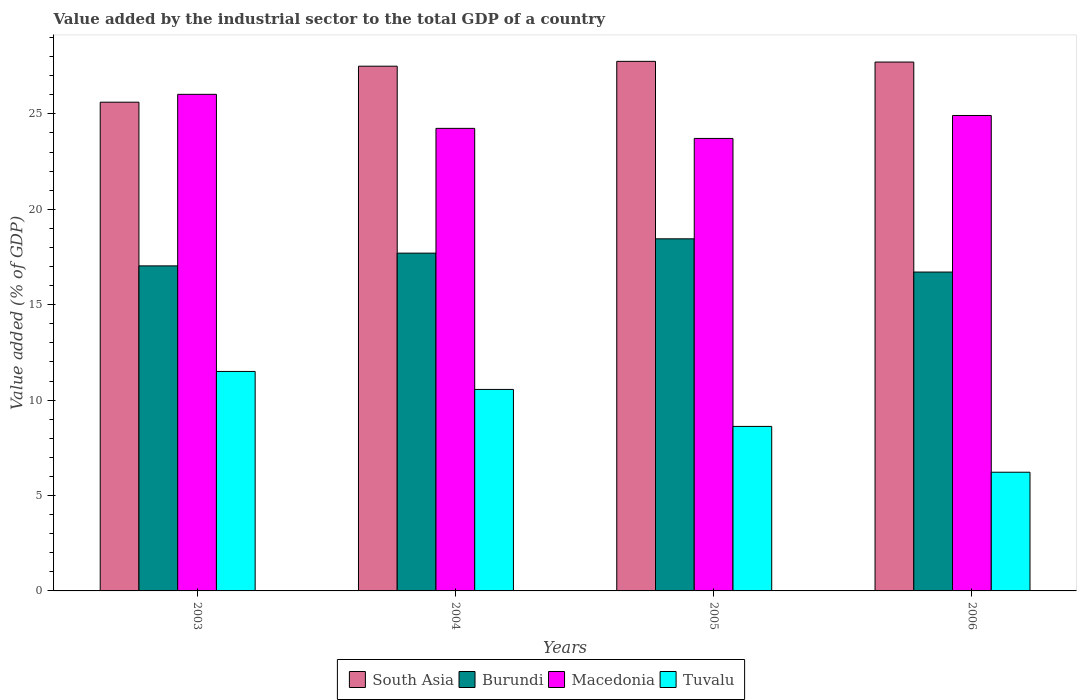How many bars are there on the 3rd tick from the left?
Make the answer very short. 4. What is the label of the 2nd group of bars from the left?
Provide a succinct answer. 2004. What is the value added by the industrial sector to the total GDP in Burundi in 2003?
Provide a short and direct response. 17.03. Across all years, what is the maximum value added by the industrial sector to the total GDP in Macedonia?
Your answer should be compact. 26.03. Across all years, what is the minimum value added by the industrial sector to the total GDP in Burundi?
Offer a very short reply. 16.71. What is the total value added by the industrial sector to the total GDP in Tuvalu in the graph?
Offer a very short reply. 36.9. What is the difference between the value added by the industrial sector to the total GDP in South Asia in 2004 and that in 2006?
Make the answer very short. -0.22. What is the difference between the value added by the industrial sector to the total GDP in Tuvalu in 2006 and the value added by the industrial sector to the total GDP in Burundi in 2004?
Make the answer very short. -11.48. What is the average value added by the industrial sector to the total GDP in Macedonia per year?
Your answer should be compact. 24.72. In the year 2006, what is the difference between the value added by the industrial sector to the total GDP in Macedonia and value added by the industrial sector to the total GDP in South Asia?
Offer a terse response. -2.8. In how many years, is the value added by the industrial sector to the total GDP in Burundi greater than 18 %?
Provide a short and direct response. 1. What is the ratio of the value added by the industrial sector to the total GDP in Macedonia in 2005 to that in 2006?
Your answer should be compact. 0.95. Is the value added by the industrial sector to the total GDP in Tuvalu in 2005 less than that in 2006?
Give a very brief answer. No. What is the difference between the highest and the second highest value added by the industrial sector to the total GDP in Macedonia?
Your answer should be compact. 1.11. What is the difference between the highest and the lowest value added by the industrial sector to the total GDP in South Asia?
Make the answer very short. 2.14. In how many years, is the value added by the industrial sector to the total GDP in Macedonia greater than the average value added by the industrial sector to the total GDP in Macedonia taken over all years?
Provide a short and direct response. 2. What does the 3rd bar from the right in 2003 represents?
Offer a terse response. Burundi. Is it the case that in every year, the sum of the value added by the industrial sector to the total GDP in South Asia and value added by the industrial sector to the total GDP in Macedonia is greater than the value added by the industrial sector to the total GDP in Burundi?
Make the answer very short. Yes. Are all the bars in the graph horizontal?
Make the answer very short. No. Are the values on the major ticks of Y-axis written in scientific E-notation?
Offer a terse response. No. Does the graph contain any zero values?
Your response must be concise. No. How many legend labels are there?
Your answer should be compact. 4. What is the title of the graph?
Ensure brevity in your answer.  Value added by the industrial sector to the total GDP of a country. What is the label or title of the Y-axis?
Your answer should be very brief. Value added (% of GDP). What is the Value added (% of GDP) in South Asia in 2003?
Your response must be concise. 25.61. What is the Value added (% of GDP) of Burundi in 2003?
Provide a short and direct response. 17.03. What is the Value added (% of GDP) of Macedonia in 2003?
Your response must be concise. 26.03. What is the Value added (% of GDP) in Tuvalu in 2003?
Keep it short and to the point. 11.5. What is the Value added (% of GDP) in South Asia in 2004?
Your answer should be very brief. 27.5. What is the Value added (% of GDP) of Burundi in 2004?
Provide a short and direct response. 17.7. What is the Value added (% of GDP) of Macedonia in 2004?
Keep it short and to the point. 24.24. What is the Value added (% of GDP) of Tuvalu in 2004?
Offer a very short reply. 10.56. What is the Value added (% of GDP) in South Asia in 2005?
Offer a terse response. 27.75. What is the Value added (% of GDP) of Burundi in 2005?
Provide a succinct answer. 18.45. What is the Value added (% of GDP) of Macedonia in 2005?
Your answer should be very brief. 23.71. What is the Value added (% of GDP) of Tuvalu in 2005?
Your answer should be very brief. 8.62. What is the Value added (% of GDP) in South Asia in 2006?
Provide a succinct answer. 27.72. What is the Value added (% of GDP) in Burundi in 2006?
Your answer should be very brief. 16.71. What is the Value added (% of GDP) in Macedonia in 2006?
Provide a short and direct response. 24.92. What is the Value added (% of GDP) in Tuvalu in 2006?
Offer a terse response. 6.22. Across all years, what is the maximum Value added (% of GDP) in South Asia?
Your answer should be compact. 27.75. Across all years, what is the maximum Value added (% of GDP) of Burundi?
Your answer should be very brief. 18.45. Across all years, what is the maximum Value added (% of GDP) of Macedonia?
Keep it short and to the point. 26.03. Across all years, what is the maximum Value added (% of GDP) in Tuvalu?
Offer a very short reply. 11.5. Across all years, what is the minimum Value added (% of GDP) in South Asia?
Provide a succinct answer. 25.61. Across all years, what is the minimum Value added (% of GDP) in Burundi?
Keep it short and to the point. 16.71. Across all years, what is the minimum Value added (% of GDP) of Macedonia?
Your answer should be very brief. 23.71. Across all years, what is the minimum Value added (% of GDP) of Tuvalu?
Give a very brief answer. 6.22. What is the total Value added (% of GDP) of South Asia in the graph?
Offer a terse response. 108.58. What is the total Value added (% of GDP) in Burundi in the graph?
Your answer should be very brief. 69.9. What is the total Value added (% of GDP) in Macedonia in the graph?
Your answer should be very brief. 98.9. What is the total Value added (% of GDP) of Tuvalu in the graph?
Make the answer very short. 36.9. What is the difference between the Value added (% of GDP) of South Asia in 2003 and that in 2004?
Keep it short and to the point. -1.89. What is the difference between the Value added (% of GDP) in Burundi in 2003 and that in 2004?
Your answer should be very brief. -0.67. What is the difference between the Value added (% of GDP) of Macedonia in 2003 and that in 2004?
Keep it short and to the point. 1.78. What is the difference between the Value added (% of GDP) of Tuvalu in 2003 and that in 2004?
Ensure brevity in your answer.  0.94. What is the difference between the Value added (% of GDP) in South Asia in 2003 and that in 2005?
Give a very brief answer. -2.14. What is the difference between the Value added (% of GDP) in Burundi in 2003 and that in 2005?
Offer a terse response. -1.42. What is the difference between the Value added (% of GDP) of Macedonia in 2003 and that in 2005?
Offer a very short reply. 2.31. What is the difference between the Value added (% of GDP) in Tuvalu in 2003 and that in 2005?
Make the answer very short. 2.88. What is the difference between the Value added (% of GDP) of South Asia in 2003 and that in 2006?
Provide a short and direct response. -2.1. What is the difference between the Value added (% of GDP) of Burundi in 2003 and that in 2006?
Your answer should be very brief. 0.32. What is the difference between the Value added (% of GDP) of Macedonia in 2003 and that in 2006?
Provide a succinct answer. 1.11. What is the difference between the Value added (% of GDP) in Tuvalu in 2003 and that in 2006?
Offer a terse response. 5.28. What is the difference between the Value added (% of GDP) of South Asia in 2004 and that in 2005?
Keep it short and to the point. -0.25. What is the difference between the Value added (% of GDP) in Burundi in 2004 and that in 2005?
Your answer should be compact. -0.75. What is the difference between the Value added (% of GDP) of Macedonia in 2004 and that in 2005?
Your response must be concise. 0.53. What is the difference between the Value added (% of GDP) in Tuvalu in 2004 and that in 2005?
Make the answer very short. 1.94. What is the difference between the Value added (% of GDP) of South Asia in 2004 and that in 2006?
Your answer should be compact. -0.22. What is the difference between the Value added (% of GDP) in Macedonia in 2004 and that in 2006?
Make the answer very short. -0.68. What is the difference between the Value added (% of GDP) in Tuvalu in 2004 and that in 2006?
Give a very brief answer. 4.34. What is the difference between the Value added (% of GDP) in South Asia in 2005 and that in 2006?
Provide a short and direct response. 0.04. What is the difference between the Value added (% of GDP) in Burundi in 2005 and that in 2006?
Your answer should be compact. 1.74. What is the difference between the Value added (% of GDP) in Macedonia in 2005 and that in 2006?
Give a very brief answer. -1.2. What is the difference between the Value added (% of GDP) of Tuvalu in 2005 and that in 2006?
Make the answer very short. 2.4. What is the difference between the Value added (% of GDP) of South Asia in 2003 and the Value added (% of GDP) of Burundi in 2004?
Ensure brevity in your answer.  7.91. What is the difference between the Value added (% of GDP) in South Asia in 2003 and the Value added (% of GDP) in Macedonia in 2004?
Your answer should be very brief. 1.37. What is the difference between the Value added (% of GDP) of South Asia in 2003 and the Value added (% of GDP) of Tuvalu in 2004?
Make the answer very short. 15.05. What is the difference between the Value added (% of GDP) of Burundi in 2003 and the Value added (% of GDP) of Macedonia in 2004?
Provide a succinct answer. -7.21. What is the difference between the Value added (% of GDP) of Burundi in 2003 and the Value added (% of GDP) of Tuvalu in 2004?
Provide a short and direct response. 6.47. What is the difference between the Value added (% of GDP) of Macedonia in 2003 and the Value added (% of GDP) of Tuvalu in 2004?
Make the answer very short. 15.47. What is the difference between the Value added (% of GDP) in South Asia in 2003 and the Value added (% of GDP) in Burundi in 2005?
Offer a very short reply. 7.16. What is the difference between the Value added (% of GDP) in South Asia in 2003 and the Value added (% of GDP) in Macedonia in 2005?
Make the answer very short. 1.9. What is the difference between the Value added (% of GDP) in South Asia in 2003 and the Value added (% of GDP) in Tuvalu in 2005?
Provide a short and direct response. 16.99. What is the difference between the Value added (% of GDP) in Burundi in 2003 and the Value added (% of GDP) in Macedonia in 2005?
Give a very brief answer. -6.68. What is the difference between the Value added (% of GDP) of Burundi in 2003 and the Value added (% of GDP) of Tuvalu in 2005?
Give a very brief answer. 8.41. What is the difference between the Value added (% of GDP) of Macedonia in 2003 and the Value added (% of GDP) of Tuvalu in 2005?
Your answer should be very brief. 17.4. What is the difference between the Value added (% of GDP) in South Asia in 2003 and the Value added (% of GDP) in Burundi in 2006?
Offer a very short reply. 8.9. What is the difference between the Value added (% of GDP) of South Asia in 2003 and the Value added (% of GDP) of Macedonia in 2006?
Ensure brevity in your answer.  0.7. What is the difference between the Value added (% of GDP) in South Asia in 2003 and the Value added (% of GDP) in Tuvalu in 2006?
Your answer should be compact. 19.39. What is the difference between the Value added (% of GDP) in Burundi in 2003 and the Value added (% of GDP) in Macedonia in 2006?
Your response must be concise. -7.88. What is the difference between the Value added (% of GDP) of Burundi in 2003 and the Value added (% of GDP) of Tuvalu in 2006?
Make the answer very short. 10.81. What is the difference between the Value added (% of GDP) in Macedonia in 2003 and the Value added (% of GDP) in Tuvalu in 2006?
Your answer should be very brief. 19.81. What is the difference between the Value added (% of GDP) of South Asia in 2004 and the Value added (% of GDP) of Burundi in 2005?
Provide a succinct answer. 9.05. What is the difference between the Value added (% of GDP) of South Asia in 2004 and the Value added (% of GDP) of Macedonia in 2005?
Your response must be concise. 3.79. What is the difference between the Value added (% of GDP) of South Asia in 2004 and the Value added (% of GDP) of Tuvalu in 2005?
Give a very brief answer. 18.88. What is the difference between the Value added (% of GDP) of Burundi in 2004 and the Value added (% of GDP) of Macedonia in 2005?
Provide a short and direct response. -6.01. What is the difference between the Value added (% of GDP) in Burundi in 2004 and the Value added (% of GDP) in Tuvalu in 2005?
Make the answer very short. 9.08. What is the difference between the Value added (% of GDP) of Macedonia in 2004 and the Value added (% of GDP) of Tuvalu in 2005?
Ensure brevity in your answer.  15.62. What is the difference between the Value added (% of GDP) in South Asia in 2004 and the Value added (% of GDP) in Burundi in 2006?
Your answer should be compact. 10.79. What is the difference between the Value added (% of GDP) in South Asia in 2004 and the Value added (% of GDP) in Macedonia in 2006?
Keep it short and to the point. 2.58. What is the difference between the Value added (% of GDP) of South Asia in 2004 and the Value added (% of GDP) of Tuvalu in 2006?
Your response must be concise. 21.28. What is the difference between the Value added (% of GDP) of Burundi in 2004 and the Value added (% of GDP) of Macedonia in 2006?
Provide a succinct answer. -7.21. What is the difference between the Value added (% of GDP) in Burundi in 2004 and the Value added (% of GDP) in Tuvalu in 2006?
Offer a terse response. 11.48. What is the difference between the Value added (% of GDP) of Macedonia in 2004 and the Value added (% of GDP) of Tuvalu in 2006?
Keep it short and to the point. 18.02. What is the difference between the Value added (% of GDP) of South Asia in 2005 and the Value added (% of GDP) of Burundi in 2006?
Provide a short and direct response. 11.04. What is the difference between the Value added (% of GDP) of South Asia in 2005 and the Value added (% of GDP) of Macedonia in 2006?
Give a very brief answer. 2.84. What is the difference between the Value added (% of GDP) of South Asia in 2005 and the Value added (% of GDP) of Tuvalu in 2006?
Give a very brief answer. 21.53. What is the difference between the Value added (% of GDP) of Burundi in 2005 and the Value added (% of GDP) of Macedonia in 2006?
Keep it short and to the point. -6.46. What is the difference between the Value added (% of GDP) of Burundi in 2005 and the Value added (% of GDP) of Tuvalu in 2006?
Ensure brevity in your answer.  12.23. What is the difference between the Value added (% of GDP) in Macedonia in 2005 and the Value added (% of GDP) in Tuvalu in 2006?
Ensure brevity in your answer.  17.49. What is the average Value added (% of GDP) of South Asia per year?
Provide a succinct answer. 27.15. What is the average Value added (% of GDP) of Burundi per year?
Give a very brief answer. 17.48. What is the average Value added (% of GDP) of Macedonia per year?
Your answer should be very brief. 24.72. What is the average Value added (% of GDP) of Tuvalu per year?
Ensure brevity in your answer.  9.23. In the year 2003, what is the difference between the Value added (% of GDP) of South Asia and Value added (% of GDP) of Burundi?
Make the answer very short. 8.58. In the year 2003, what is the difference between the Value added (% of GDP) in South Asia and Value added (% of GDP) in Macedonia?
Make the answer very short. -0.41. In the year 2003, what is the difference between the Value added (% of GDP) in South Asia and Value added (% of GDP) in Tuvalu?
Provide a succinct answer. 14.11. In the year 2003, what is the difference between the Value added (% of GDP) of Burundi and Value added (% of GDP) of Macedonia?
Ensure brevity in your answer.  -8.99. In the year 2003, what is the difference between the Value added (% of GDP) of Burundi and Value added (% of GDP) of Tuvalu?
Your answer should be very brief. 5.53. In the year 2003, what is the difference between the Value added (% of GDP) of Macedonia and Value added (% of GDP) of Tuvalu?
Offer a very short reply. 14.52. In the year 2004, what is the difference between the Value added (% of GDP) in South Asia and Value added (% of GDP) in Burundi?
Offer a terse response. 9.8. In the year 2004, what is the difference between the Value added (% of GDP) of South Asia and Value added (% of GDP) of Macedonia?
Give a very brief answer. 3.26. In the year 2004, what is the difference between the Value added (% of GDP) in South Asia and Value added (% of GDP) in Tuvalu?
Keep it short and to the point. 16.94. In the year 2004, what is the difference between the Value added (% of GDP) of Burundi and Value added (% of GDP) of Macedonia?
Offer a very short reply. -6.54. In the year 2004, what is the difference between the Value added (% of GDP) of Burundi and Value added (% of GDP) of Tuvalu?
Your answer should be compact. 7.14. In the year 2004, what is the difference between the Value added (% of GDP) in Macedonia and Value added (% of GDP) in Tuvalu?
Your answer should be very brief. 13.68. In the year 2005, what is the difference between the Value added (% of GDP) in South Asia and Value added (% of GDP) in Burundi?
Make the answer very short. 9.3. In the year 2005, what is the difference between the Value added (% of GDP) in South Asia and Value added (% of GDP) in Macedonia?
Your answer should be compact. 4.04. In the year 2005, what is the difference between the Value added (% of GDP) of South Asia and Value added (% of GDP) of Tuvalu?
Give a very brief answer. 19.13. In the year 2005, what is the difference between the Value added (% of GDP) in Burundi and Value added (% of GDP) in Macedonia?
Give a very brief answer. -5.26. In the year 2005, what is the difference between the Value added (% of GDP) in Burundi and Value added (% of GDP) in Tuvalu?
Provide a short and direct response. 9.83. In the year 2005, what is the difference between the Value added (% of GDP) of Macedonia and Value added (% of GDP) of Tuvalu?
Your answer should be compact. 15.09. In the year 2006, what is the difference between the Value added (% of GDP) in South Asia and Value added (% of GDP) in Burundi?
Ensure brevity in your answer.  11.01. In the year 2006, what is the difference between the Value added (% of GDP) in South Asia and Value added (% of GDP) in Macedonia?
Your answer should be very brief. 2.8. In the year 2006, what is the difference between the Value added (% of GDP) in South Asia and Value added (% of GDP) in Tuvalu?
Provide a short and direct response. 21.5. In the year 2006, what is the difference between the Value added (% of GDP) in Burundi and Value added (% of GDP) in Macedonia?
Give a very brief answer. -8.21. In the year 2006, what is the difference between the Value added (% of GDP) of Burundi and Value added (% of GDP) of Tuvalu?
Your answer should be compact. 10.49. In the year 2006, what is the difference between the Value added (% of GDP) in Macedonia and Value added (% of GDP) in Tuvalu?
Provide a succinct answer. 18.7. What is the ratio of the Value added (% of GDP) of South Asia in 2003 to that in 2004?
Your response must be concise. 0.93. What is the ratio of the Value added (% of GDP) in Burundi in 2003 to that in 2004?
Ensure brevity in your answer.  0.96. What is the ratio of the Value added (% of GDP) of Macedonia in 2003 to that in 2004?
Provide a succinct answer. 1.07. What is the ratio of the Value added (% of GDP) in Tuvalu in 2003 to that in 2004?
Provide a succinct answer. 1.09. What is the ratio of the Value added (% of GDP) in South Asia in 2003 to that in 2005?
Your answer should be compact. 0.92. What is the ratio of the Value added (% of GDP) in Macedonia in 2003 to that in 2005?
Provide a short and direct response. 1.1. What is the ratio of the Value added (% of GDP) in Tuvalu in 2003 to that in 2005?
Offer a very short reply. 1.33. What is the ratio of the Value added (% of GDP) of South Asia in 2003 to that in 2006?
Offer a very short reply. 0.92. What is the ratio of the Value added (% of GDP) in Burundi in 2003 to that in 2006?
Give a very brief answer. 1.02. What is the ratio of the Value added (% of GDP) of Macedonia in 2003 to that in 2006?
Make the answer very short. 1.04. What is the ratio of the Value added (% of GDP) in Tuvalu in 2003 to that in 2006?
Your answer should be very brief. 1.85. What is the ratio of the Value added (% of GDP) of South Asia in 2004 to that in 2005?
Give a very brief answer. 0.99. What is the ratio of the Value added (% of GDP) in Burundi in 2004 to that in 2005?
Your answer should be very brief. 0.96. What is the ratio of the Value added (% of GDP) of Macedonia in 2004 to that in 2005?
Provide a succinct answer. 1.02. What is the ratio of the Value added (% of GDP) in Tuvalu in 2004 to that in 2005?
Give a very brief answer. 1.22. What is the ratio of the Value added (% of GDP) in South Asia in 2004 to that in 2006?
Keep it short and to the point. 0.99. What is the ratio of the Value added (% of GDP) of Burundi in 2004 to that in 2006?
Offer a terse response. 1.06. What is the ratio of the Value added (% of GDP) in Macedonia in 2004 to that in 2006?
Offer a very short reply. 0.97. What is the ratio of the Value added (% of GDP) in Tuvalu in 2004 to that in 2006?
Offer a terse response. 1.7. What is the ratio of the Value added (% of GDP) in Burundi in 2005 to that in 2006?
Offer a terse response. 1.1. What is the ratio of the Value added (% of GDP) of Macedonia in 2005 to that in 2006?
Provide a short and direct response. 0.95. What is the ratio of the Value added (% of GDP) in Tuvalu in 2005 to that in 2006?
Offer a terse response. 1.39. What is the difference between the highest and the second highest Value added (% of GDP) in South Asia?
Offer a very short reply. 0.04. What is the difference between the highest and the second highest Value added (% of GDP) of Burundi?
Provide a succinct answer. 0.75. What is the difference between the highest and the second highest Value added (% of GDP) in Macedonia?
Your response must be concise. 1.11. What is the difference between the highest and the second highest Value added (% of GDP) of Tuvalu?
Keep it short and to the point. 0.94. What is the difference between the highest and the lowest Value added (% of GDP) of South Asia?
Keep it short and to the point. 2.14. What is the difference between the highest and the lowest Value added (% of GDP) in Burundi?
Your answer should be compact. 1.74. What is the difference between the highest and the lowest Value added (% of GDP) of Macedonia?
Your answer should be very brief. 2.31. What is the difference between the highest and the lowest Value added (% of GDP) of Tuvalu?
Offer a very short reply. 5.28. 